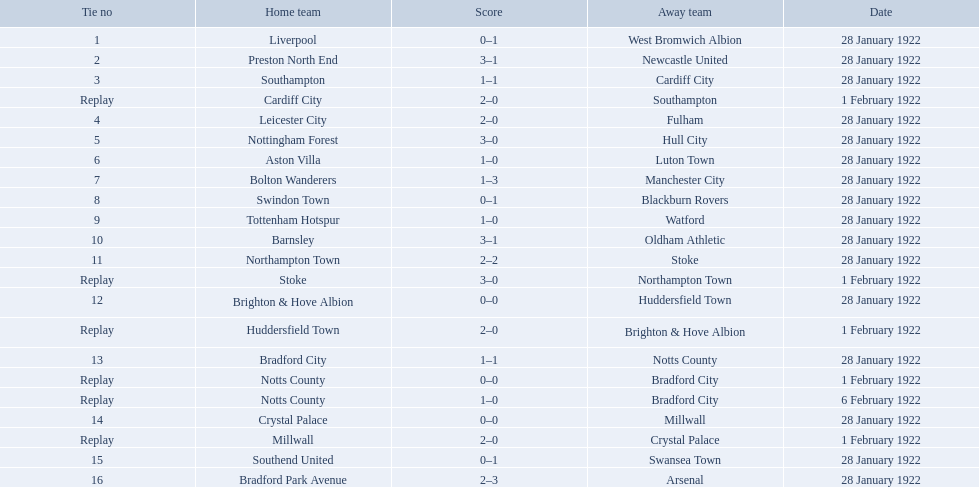Which team had a score of 0-1? Liverpool. Which team had a replay? Cardiff City. Which team had the same score as aston villa? Tottenham Hotspur. What was the score in the aston villa game? 1–0. Which other team had an identical score? Tottenham Hotspur. Which squad achieved a 0-1 score? Liverpool. Which squad had a repetition? Cardiff City. Which squad had a similar score to aston villa? Tottenham Hotspur. What was the outcome in the aston villa game? 1–0. Which other team had an equivalent outcome? Tottenham Hotspur. Which unit recorded a 0-1 tally? Liverpool. Which unit experienced a replay? Cardiff City. Which unit had an equal score as aston villa? Tottenham Hotspur. What is the list of home teams? Liverpool, Preston North End, Southampton, Cardiff City, Leicester City, Nottingham Forest, Aston Villa, Bolton Wanderers, Swindon Town, Tottenham Hotspur, Barnsley, Northampton Town, Stoke, Brighton & Hove Albion, Huddersfield Town, Bradford City, Notts County, Notts County, Crystal Palace, Millwall, Southend United, Bradford Park Avenue. What were the outcomes? 0–1, 3–1, 1–1, 2–0, 2–0, 3–0, 1–0, 1–3, 0–1, 1–0, 3–1, 2–2, 3–0, 0–0, 2–0, 1–1, 0–0, 1–0, 0–0, 2–0, 0–1, 2–3. When did the matches take place? 28 January 1922, 28 January 1922, 28 January 1922, 1 February 1922, 28 January 1922, 28 January 1922, 28 January 1922, 28 January 1922, 28 January 1922, 28 January 1922, 28 January 1922, 28 January 1922, 1 February 1922, 28 January 1922, 1 February 1922, 28 January 1922, 1 February 1922, 6 February 1922, 28 January 1922, 1 February 1922, 28 January 1922, 28 January 1922. Which teams competed on january 28, 1922? Liverpool, Preston North End, Southampton, Leicester City, Nottingham Forest, Aston Villa, Bolton Wanderers, Swindon Town, Tottenham Hotspur, Barnsley, Northampton Town, Brighton & Hove Albion, Bradford City, Crystal Palace, Southend United, Bradford Park Avenue. Among them, who had a score similar to aston villa? Tottenham Hotspur. Who are all the home teams? Liverpool, Preston North End, Southampton, Cardiff City, Leicester City, Nottingham Forest, Aston Villa, Bolton Wanderers, Swindon Town, Tottenham Hotspur, Barnsley, Northampton Town, Stoke, Brighton & Hove Albion, Huddersfield Town, Bradford City, Notts County, Notts County, Crystal Palace, Millwall, Southend United, Bradford Park Avenue. What were the results? 0–1, 3–1, 1–1, 2–0, 2–0, 3–0, 1–0, 1–3, 0–1, 1–0, 3–1, 2–2, 3–0, 0–0, 2–0, 1–1, 0–0, 1–0, 0–0, 2–0, 0–1, 2–3. When were the games played? 28 January 1922, 28 January 1922, 28 January 1922, 1 February 1922, 28 January 1922, 28 January 1922, 28 January 1922, 28 January 1922, 28 January 1922, 28 January 1922, 28 January 1922, 28 January 1922, 1 February 1922, 28 January 1922, 1 February 1922, 28 January 1922, 1 February 1922, 6 February 1922, 28 January 1922, 1 February 1922, 28 January 1922, 28 January 1922. Which teams participated on january 28, 1922? Liverpool, Preston North End, Southampton, Leicester City, Nottingham Forest, Aston Villa, Bolton Wanderers, Swindon Town, Tottenham Hotspur, Barnsley, Northampton Town, Brighton & Hove Albion, Bradford City, Crystal Palace, Southend United, Bradford Park Avenue. From them, who had an equal score as aston villa? Tottenham Hotspur. 